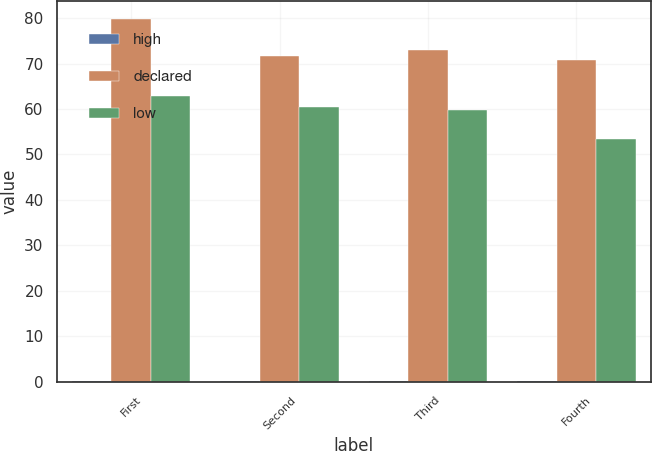<chart> <loc_0><loc_0><loc_500><loc_500><stacked_bar_chart><ecel><fcel>First<fcel>Second<fcel>Third<fcel>Fourth<nl><fcel>high<fcel>0.25<fcel>0.28<fcel>0.28<fcel>0.28<nl><fcel>declared<fcel>79.69<fcel>71.58<fcel>72.89<fcel>70.76<nl><fcel>low<fcel>62.82<fcel>60.36<fcel>59.82<fcel>53.43<nl></chart> 